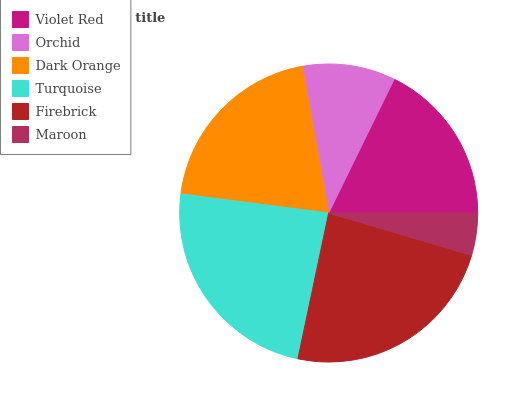Is Maroon the minimum?
Answer yes or no. Yes. Is Turquoise the maximum?
Answer yes or no. Yes. Is Orchid the minimum?
Answer yes or no. No. Is Orchid the maximum?
Answer yes or no. No. Is Violet Red greater than Orchid?
Answer yes or no. Yes. Is Orchid less than Violet Red?
Answer yes or no. Yes. Is Orchid greater than Violet Red?
Answer yes or no. No. Is Violet Red less than Orchid?
Answer yes or no. No. Is Dark Orange the high median?
Answer yes or no. Yes. Is Violet Red the low median?
Answer yes or no. Yes. Is Turquoise the high median?
Answer yes or no. No. Is Orchid the low median?
Answer yes or no. No. 